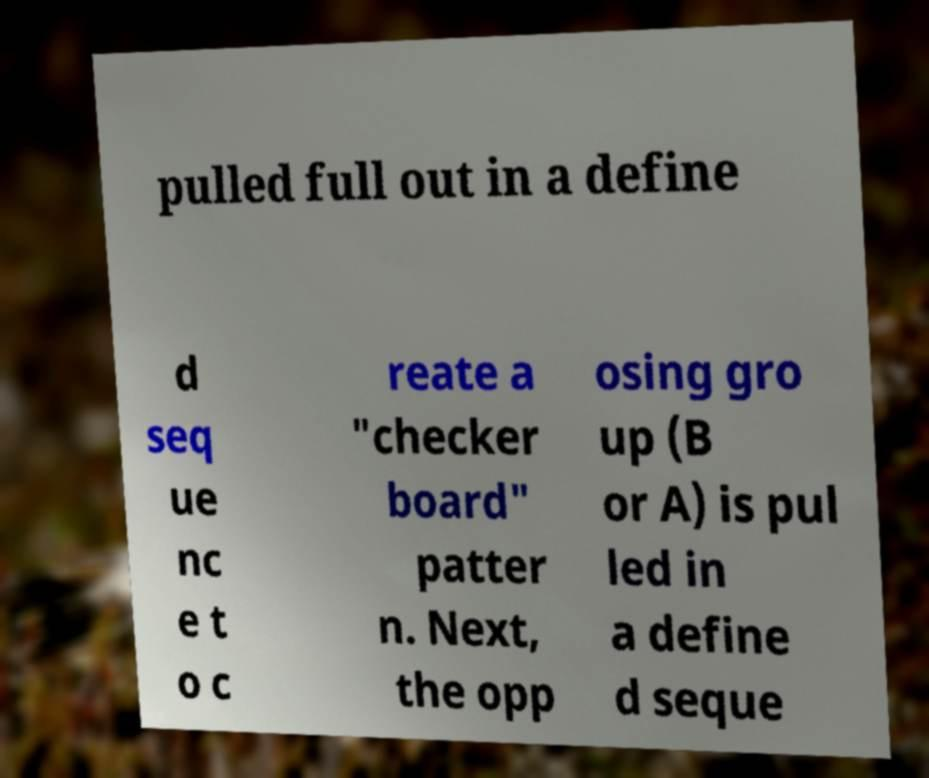Could you extract and type out the text from this image? pulled full out in a define d seq ue nc e t o c reate a "checker board" patter n. Next, the opp osing gro up (B or A) is pul led in a define d seque 